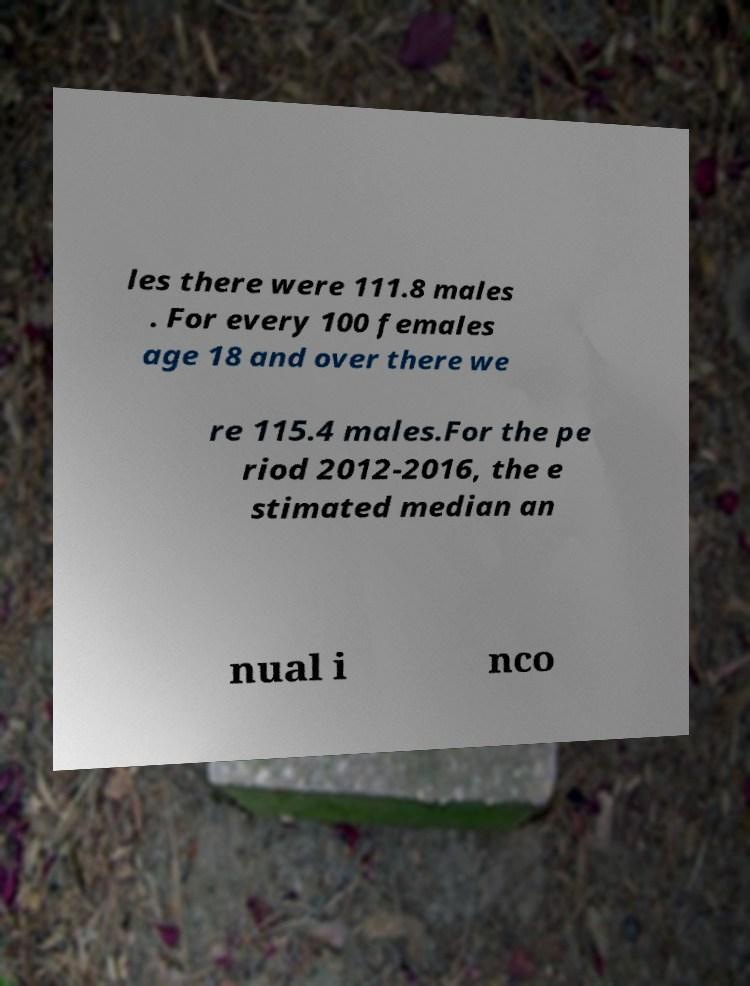Please read and relay the text visible in this image. What does it say? les there were 111.8 males . For every 100 females age 18 and over there we re 115.4 males.For the pe riod 2012-2016, the e stimated median an nual i nco 